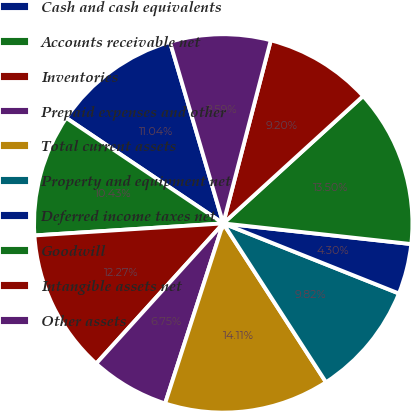Convert chart to OTSL. <chart><loc_0><loc_0><loc_500><loc_500><pie_chart><fcel>Cash and cash equivalents<fcel>Accounts receivable net<fcel>Inventories<fcel>Prepaid expenses and other<fcel>Total current assets<fcel>Property and equipment net<fcel>Deferred income taxes net<fcel>Goodwill<fcel>Intangible assets net<fcel>Other assets<nl><fcel>11.04%<fcel>10.43%<fcel>12.27%<fcel>6.75%<fcel>14.11%<fcel>9.82%<fcel>4.3%<fcel>13.5%<fcel>9.2%<fcel>8.59%<nl></chart> 